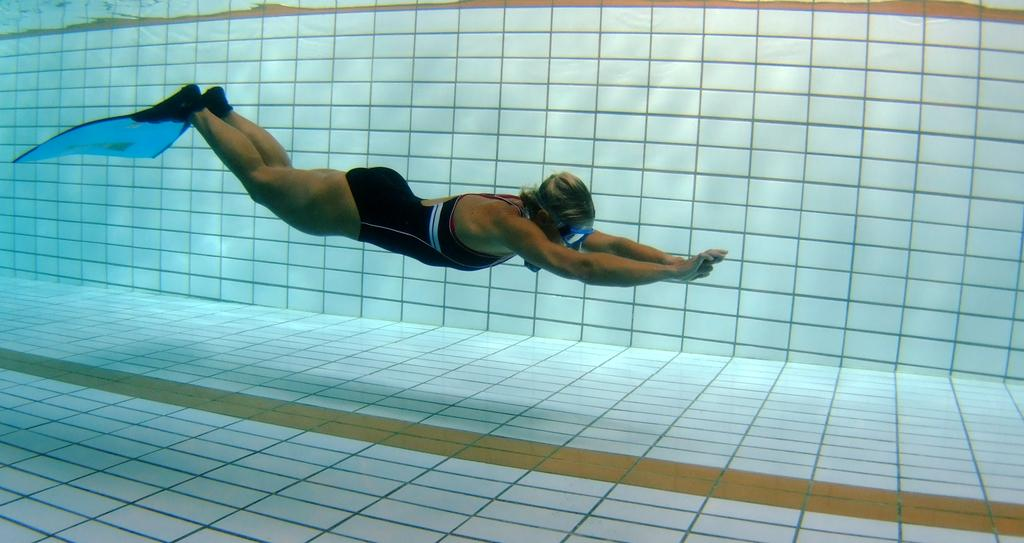What is the main subject of the image? The main subject of the image is a woman. What is the woman doing in the image? The woman is swimming in the water. What can be seen in the background of the image? There is a wall in the background of the image. How many fish are visible in the image? There are no fish visible in the image; it features a woman swimming in the water. Is there any ice present in the image? There is no ice present in the image. 